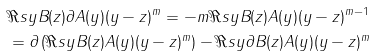Convert formula to latex. <formula><loc_0><loc_0><loc_500><loc_500>& \Re s y B ( z ) \partial A ( y ) ( y - z ) ^ { m } = - m \Re s y B ( z ) A ( y ) ( y - z ) ^ { m - 1 } \\ & = \partial \left ( \Re s y B ( z ) A ( y ) ( y - z ) ^ { m } \right ) - \Re s y \partial B ( z ) A ( y ) ( y - z ) ^ { m }</formula> 